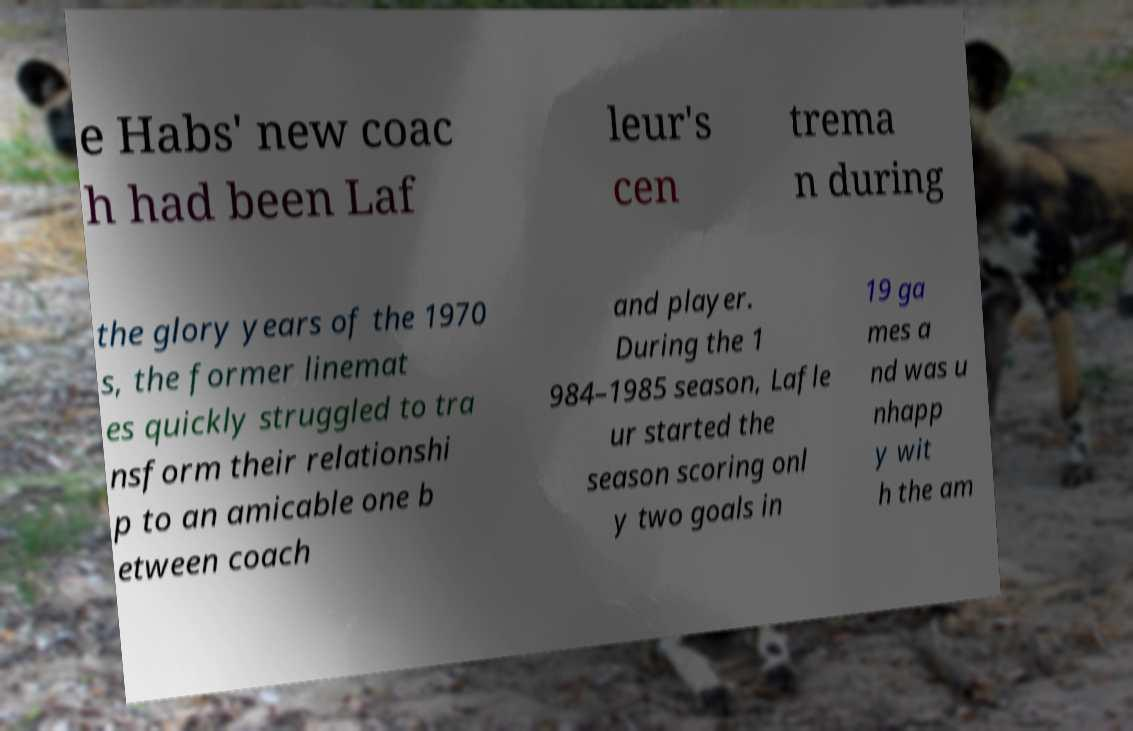Can you read and provide the text displayed in the image?This photo seems to have some interesting text. Can you extract and type it out for me? e Habs' new coac h had been Laf leur's cen trema n during the glory years of the 1970 s, the former linemat es quickly struggled to tra nsform their relationshi p to an amicable one b etween coach and player. During the 1 984–1985 season, Lafle ur started the season scoring onl y two goals in 19 ga mes a nd was u nhapp y wit h the am 